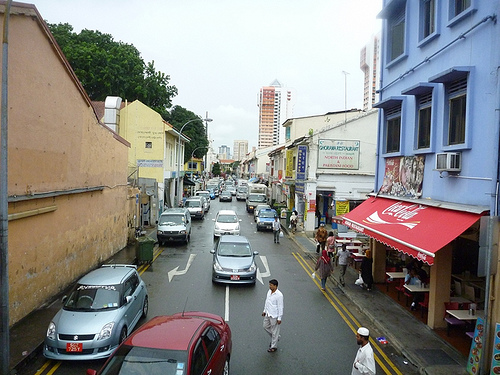<image>
Is there a man behind the car? No. The man is not behind the car. From this viewpoint, the man appears to be positioned elsewhere in the scene. 